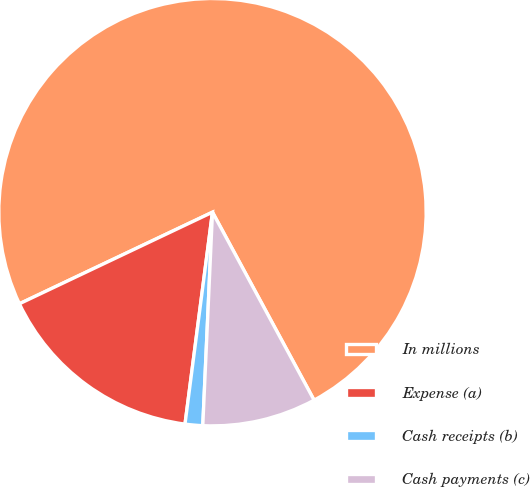Convert chart to OTSL. <chart><loc_0><loc_0><loc_500><loc_500><pie_chart><fcel>In millions<fcel>Expense (a)<fcel>Cash receipts (b)<fcel>Cash payments (c)<nl><fcel>74.17%<fcel>15.9%<fcel>1.33%<fcel>8.61%<nl></chart> 